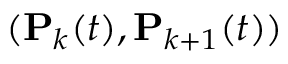<formula> <loc_0><loc_0><loc_500><loc_500>( P _ { k } ( t ) , P _ { k + 1 } ( t ) )</formula> 